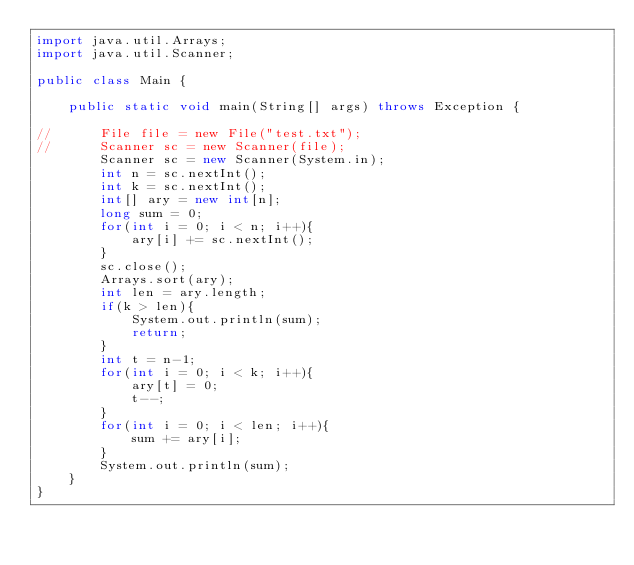<code> <loc_0><loc_0><loc_500><loc_500><_Java_>import java.util.Arrays;
import java.util.Scanner;

public class Main {

    public static void main(String[] args) throws Exception {

//    	File file = new File("test.txt");
//    	Scanner sc = new Scanner(file);
    	Scanner sc = new Scanner(System.in);
    	int n = sc.nextInt();
    	int k = sc.nextInt();
    	int[] ary = new int[n];
    	long sum = 0;
    	for(int i = 0; i < n; i++){
    		ary[i] += sc.nextInt();
    	}
    	sc.close();
    	Arrays.sort(ary);
    	int len = ary.length;
    	if(k > len){
    		System.out.println(sum);
    		return;
    	}
    	int t = n-1;
    	for(int i = 0; i < k; i++){
    		ary[t] = 0;
    		t--;
    	}
    	for(int i = 0; i < len; i++){
    		sum += ary[i];
    	}
    	System.out.println(sum);
    }
}</code> 